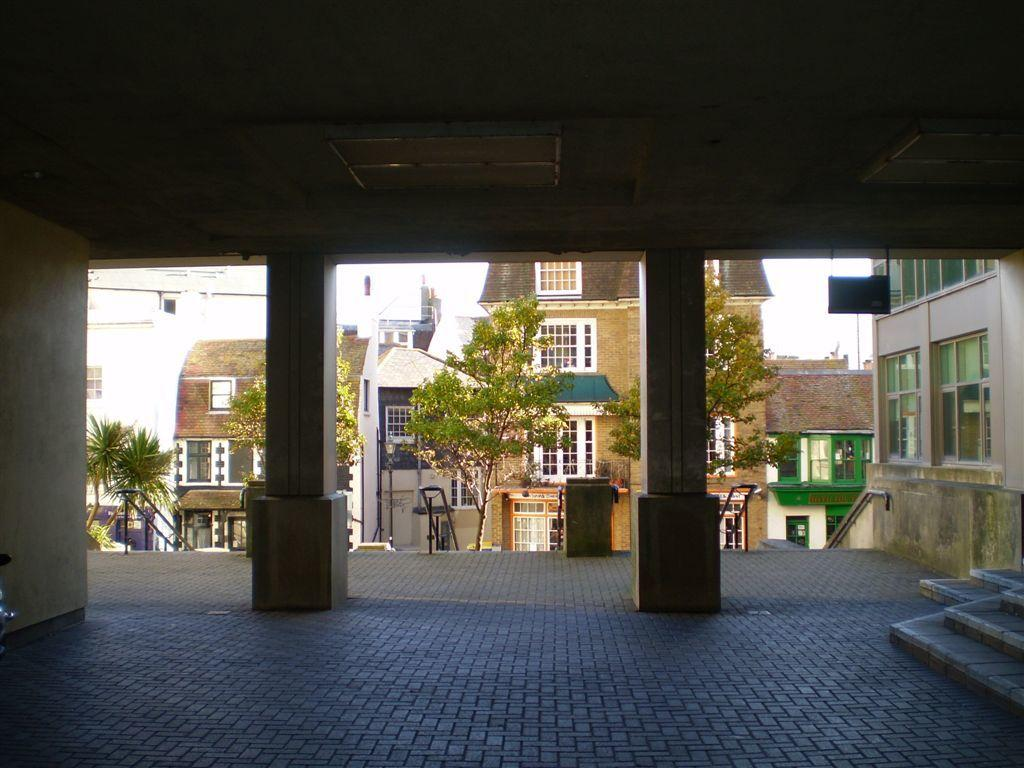What architectural features can be seen in the image? There are pillars and buildings with windows in the image. What is the purpose of the roof in the image? The roof provides shelter and protection from the elements. What can be seen on the ground in the image? The ground is visible in the image. Are there any structures that allow for vertical movement in the image? Yes, there are stairs in the image. What else can be seen in the image besides the buildings and stairs? There are rods and the sky visible in the image. Can you see any children playing on the playground in the image? There is no playground present in the image. What type of tub is visible in the image? There is no tub present in the image. 